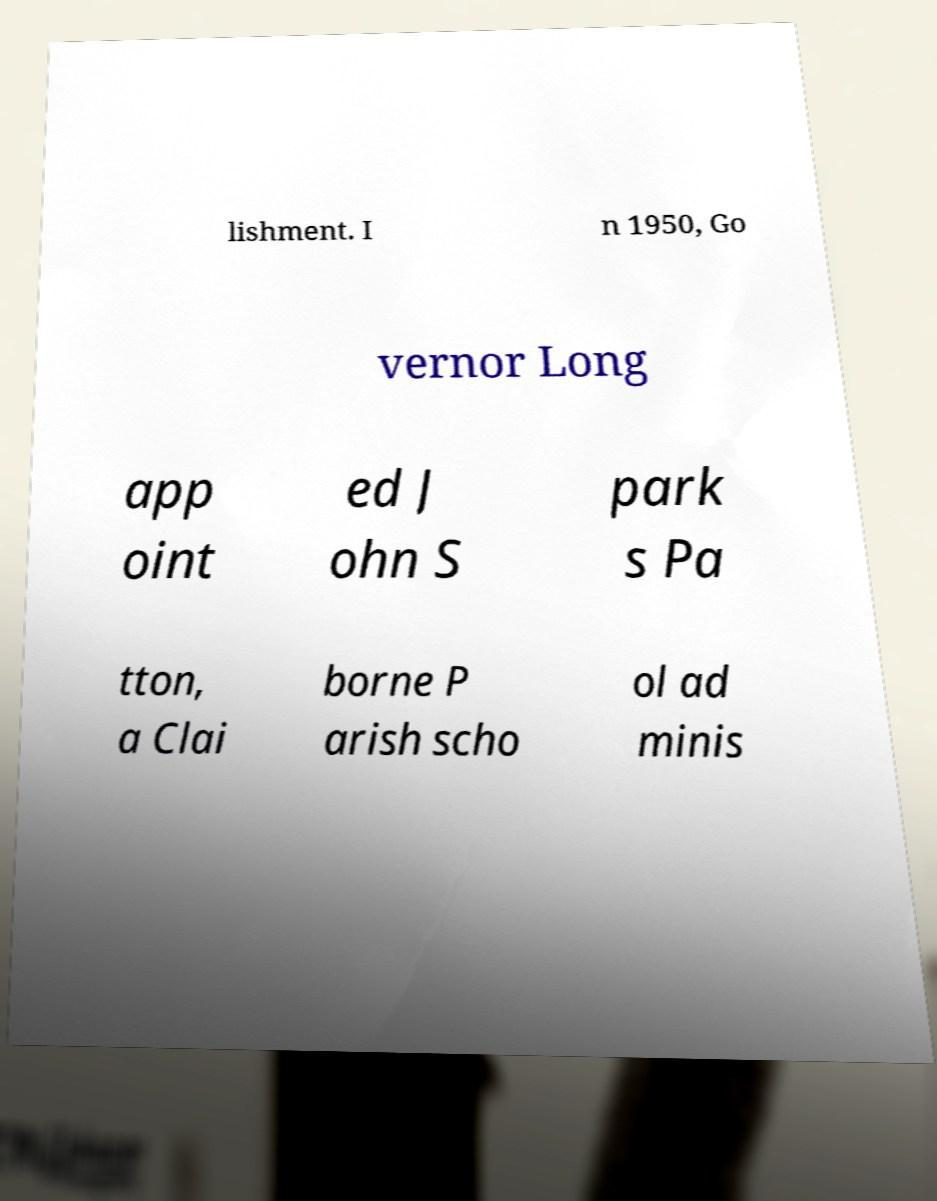Please identify and transcribe the text found in this image. lishment. I n 1950, Go vernor Long app oint ed J ohn S park s Pa tton, a Clai borne P arish scho ol ad minis 